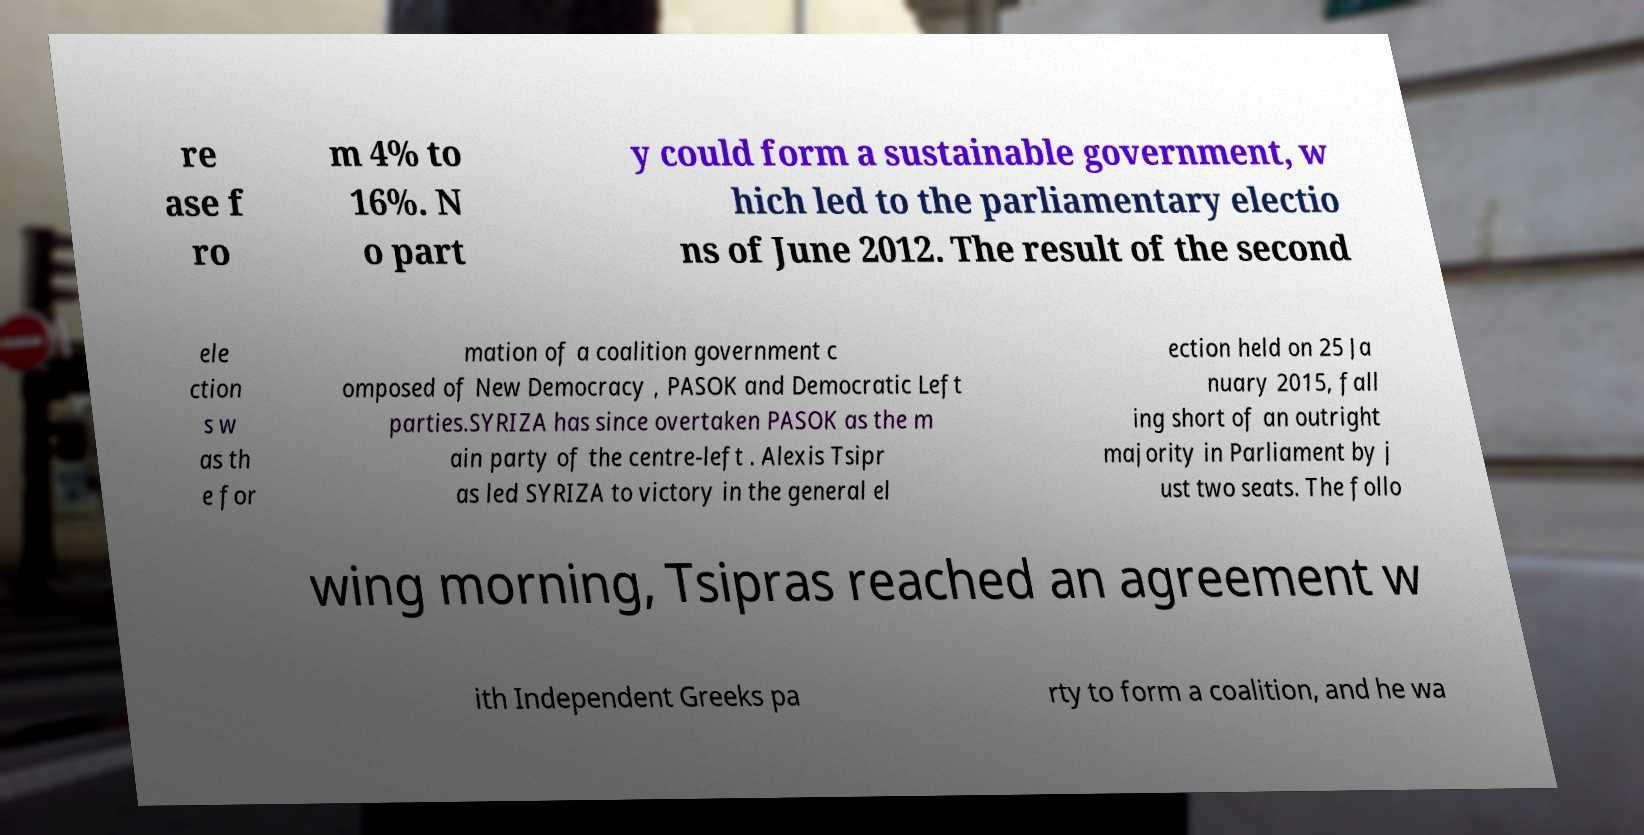Can you read and provide the text displayed in the image?This photo seems to have some interesting text. Can you extract and type it out for me? re ase f ro m 4% to 16%. N o part y could form a sustainable government, w hich led to the parliamentary electio ns of June 2012. The result of the second ele ction s w as th e for mation of a coalition government c omposed of New Democracy , PASOK and Democratic Left parties.SYRIZA has since overtaken PASOK as the m ain party of the centre-left . Alexis Tsipr as led SYRIZA to victory in the general el ection held on 25 Ja nuary 2015, fall ing short of an outright majority in Parliament by j ust two seats. The follo wing morning, Tsipras reached an agreement w ith Independent Greeks pa rty to form a coalition, and he wa 